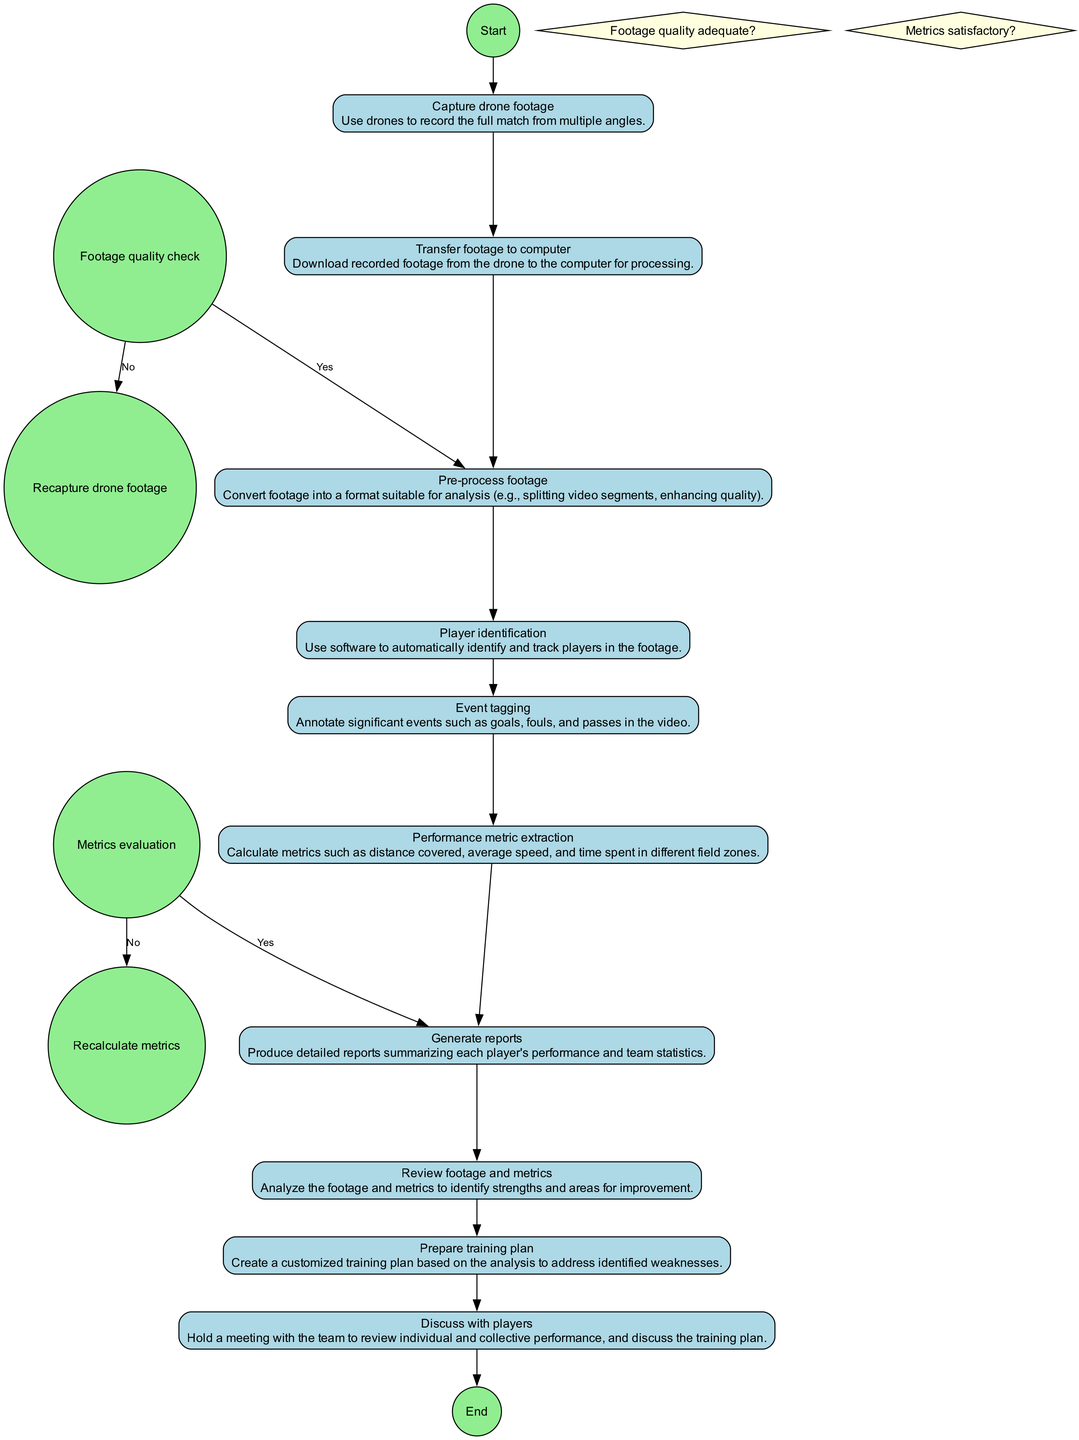What is the first activity in the diagram? The first activity listed in the diagram is "Capture drone footage." It is the activity that initiates the process.
Answer: Capture drone footage How many activities are there in total? By counting all the activities listed in the diagram, there are ten activities in total related to post-match footage processing and player performance evaluation.
Answer: Ten What is the final activity before the end node? The last activity that occurs before reaching the end node is "Discuss with players." It signifies the conclusion of the process.
Answer: Discuss with players What happens if the footage quality is not adequate? If the footage quality is not adequate, the next activity is "Recapture drone footage," indicating that the process will need to go back and redo part of it.
Answer: Recapture drone footage What metric is generated after performance metric extraction? The output of "Generate reports" is a summary of each player's performance and team statistics, which is the next step after extracting performance metrics.
Answer: Generate reports What decision is made after pre-processing footage? The decision that follows pre-process footage is "Footage quality adequate?" The result of this decision influences whether to continue with analysis or recapture footage.
Answer: Footage quality adequate? How many decision points are present in the diagram? The diagram contains two decision points: "Footage quality adequate?" and "Metrics satisfactory?" Each decision guides the subsequent actions based on the condition being true or false.
Answer: Two What is the activity that follows event tagging? Following "Event tagging," the next activity is "Performance metric extraction," which focuses on calculating different performance metrics for analysis.
Answer: Performance metric extraction What does the activity "Prepare training plan" rely on? The "Prepare training plan" activity is dependent on the analysis conducted in the "Review footage and metrics," as it is based on identified strengths and weaknesses.
Answer: Review footage and metrics 